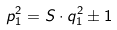<formula> <loc_0><loc_0><loc_500><loc_500>p _ { 1 } ^ { 2 } = S \cdot q _ { 1 } ^ { 2 } \pm 1</formula> 